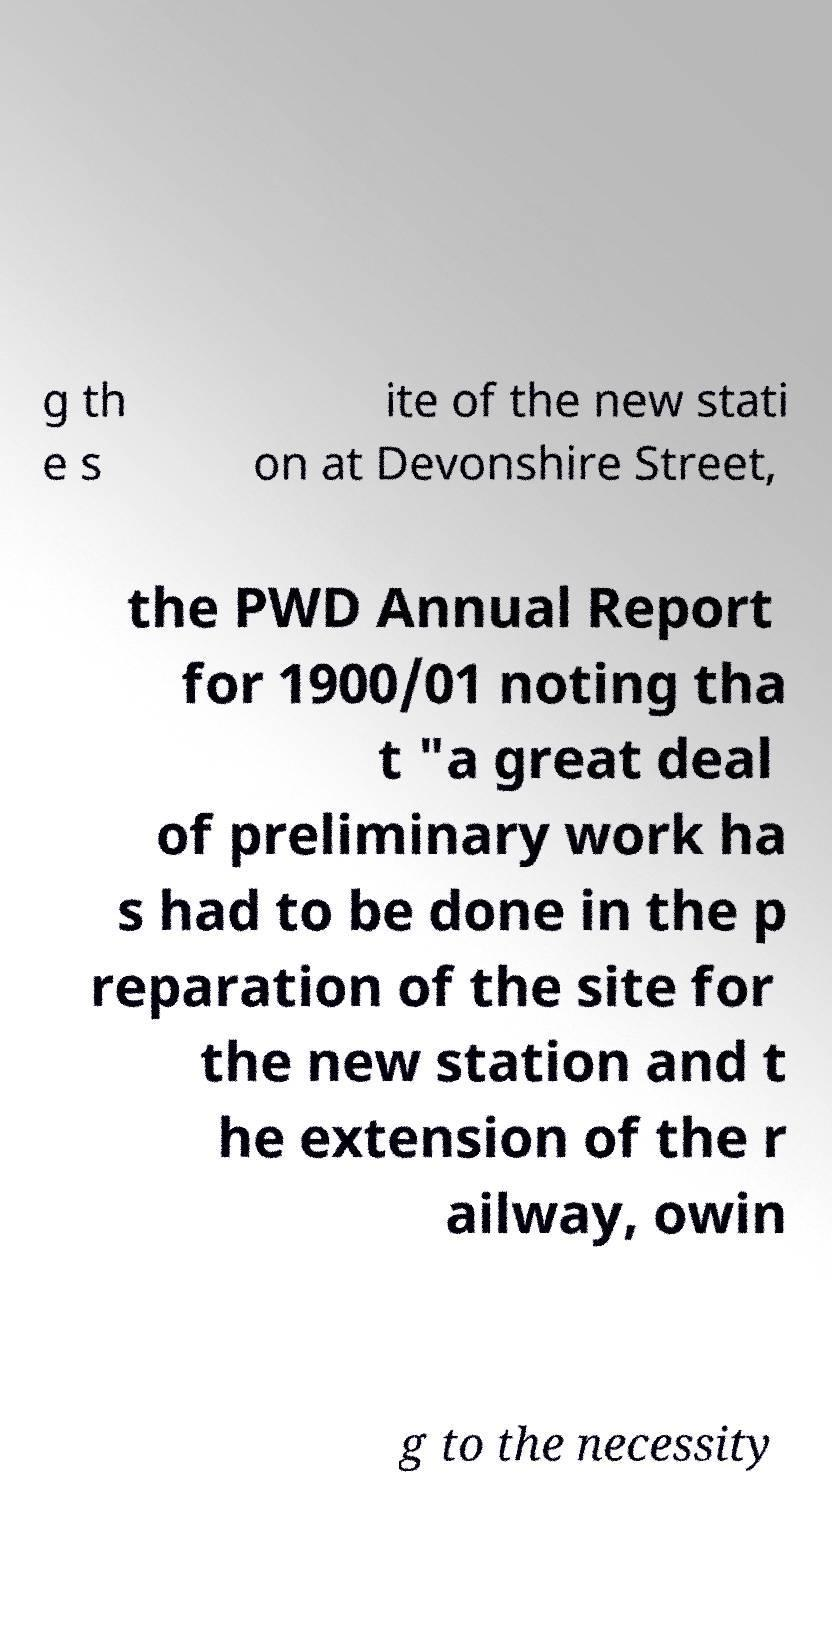Please identify and transcribe the text found in this image. g th e s ite of the new stati on at Devonshire Street, the PWD Annual Report for 1900/01 noting tha t "a great deal of preliminary work ha s had to be done in the p reparation of the site for the new station and t he extension of the r ailway, owin g to the necessity 